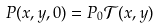Convert formula to latex. <formula><loc_0><loc_0><loc_500><loc_500>P ( x , y , 0 ) = P _ { 0 } \mathcal { T } ( x , y )</formula> 